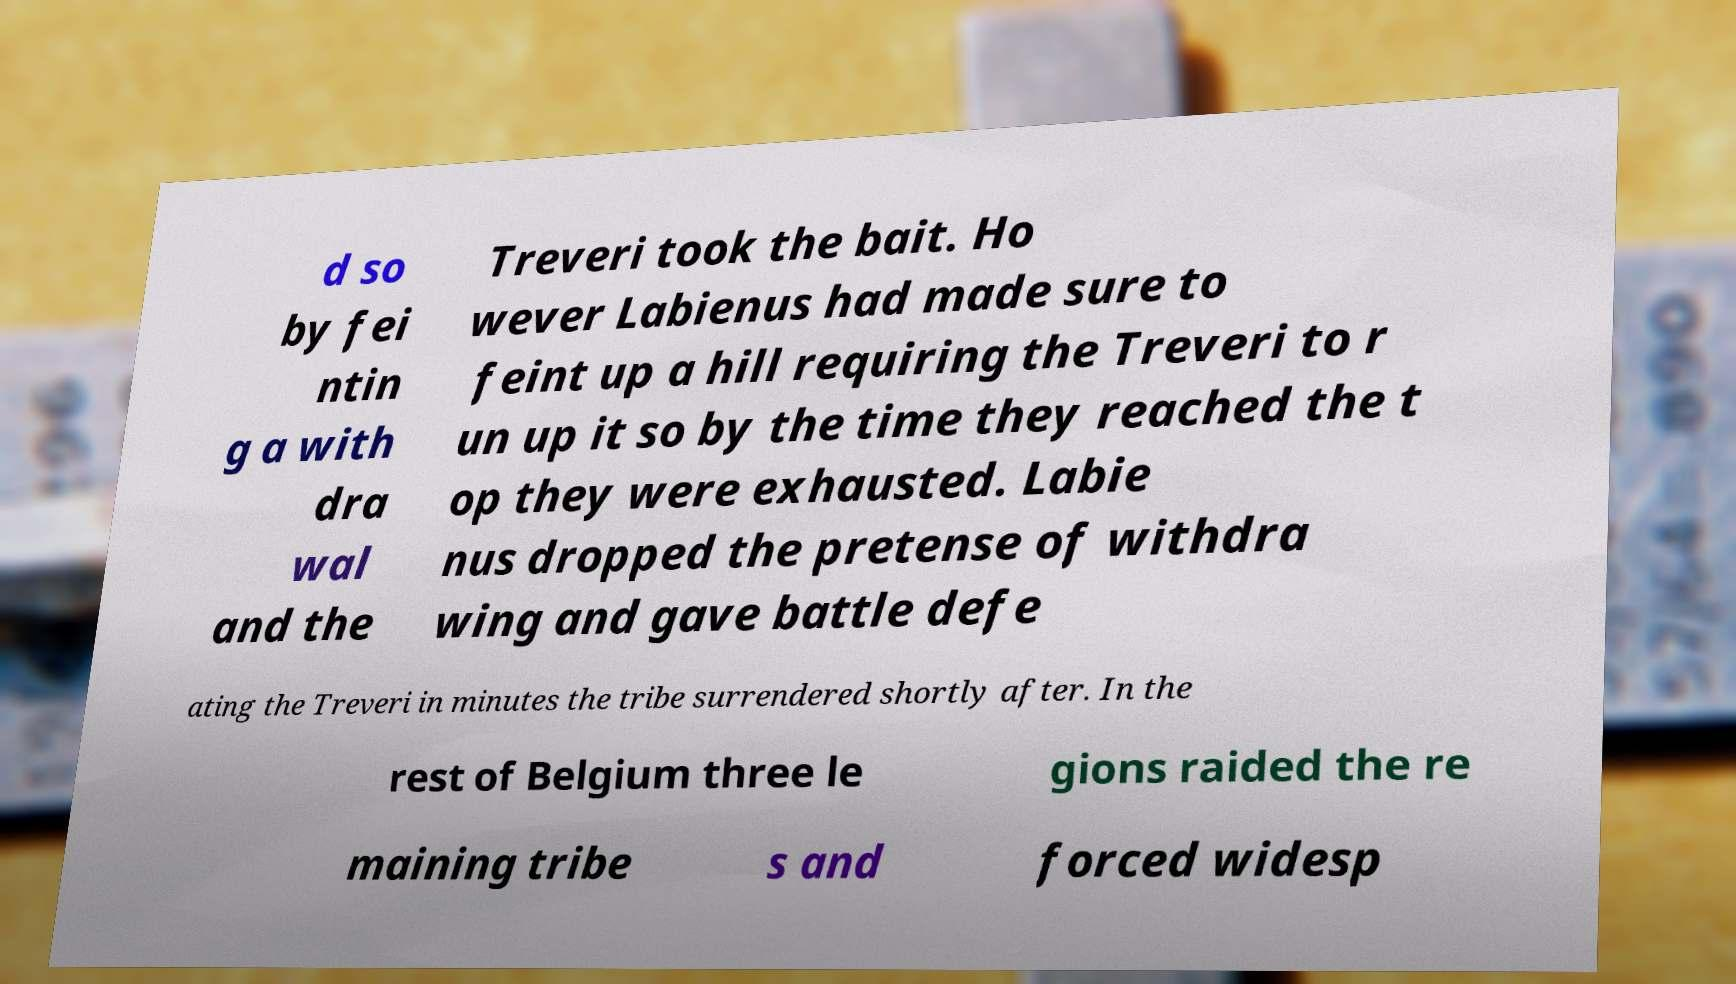Please read and relay the text visible in this image. What does it say? d so by fei ntin g a with dra wal and the Treveri took the bait. Ho wever Labienus had made sure to feint up a hill requiring the Treveri to r un up it so by the time they reached the t op they were exhausted. Labie nus dropped the pretense of withdra wing and gave battle defe ating the Treveri in minutes the tribe surrendered shortly after. In the rest of Belgium three le gions raided the re maining tribe s and forced widesp 